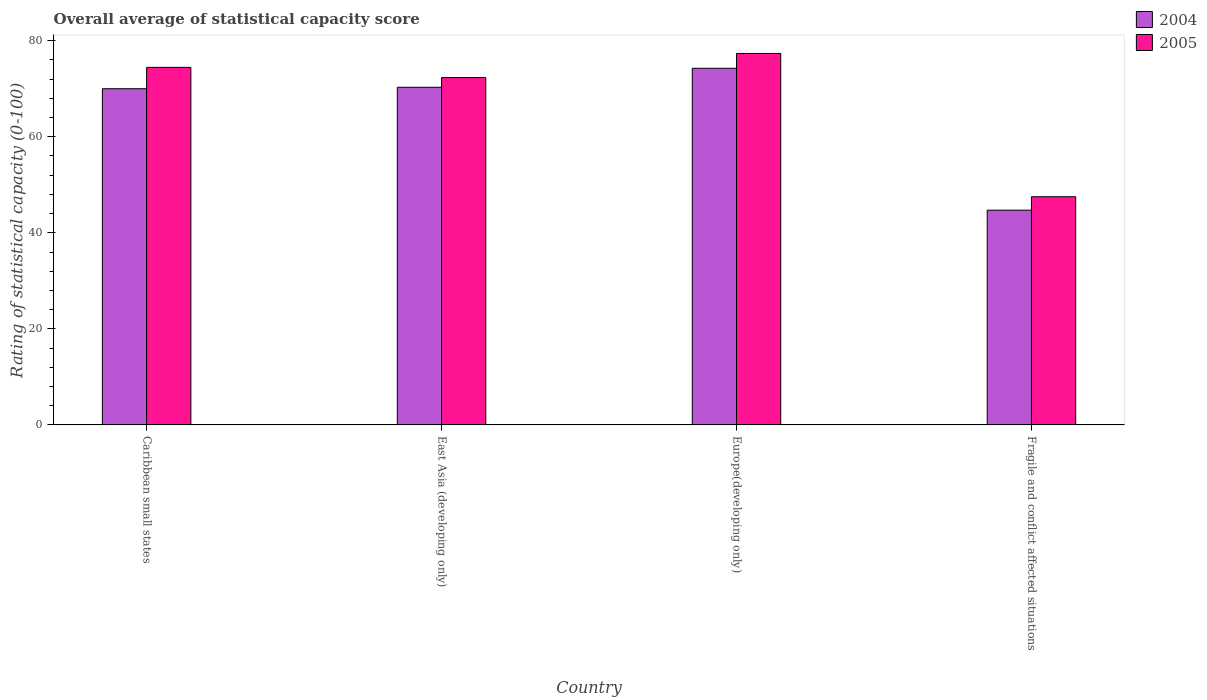How many groups of bars are there?
Offer a very short reply. 4. Are the number of bars per tick equal to the number of legend labels?
Give a very brief answer. Yes. Are the number of bars on each tick of the X-axis equal?
Give a very brief answer. Yes. How many bars are there on the 4th tick from the left?
Your response must be concise. 2. What is the label of the 3rd group of bars from the left?
Offer a very short reply. Europe(developing only). In how many cases, is the number of bars for a given country not equal to the number of legend labels?
Ensure brevity in your answer.  0. What is the rating of statistical capacity in 2004 in Europe(developing only)?
Make the answer very short. 74.26. Across all countries, what is the maximum rating of statistical capacity in 2005?
Provide a succinct answer. 77.35. Across all countries, what is the minimum rating of statistical capacity in 2005?
Keep it short and to the point. 47.51. In which country was the rating of statistical capacity in 2005 maximum?
Give a very brief answer. Europe(developing only). In which country was the rating of statistical capacity in 2005 minimum?
Provide a short and direct response. Fragile and conflict affected situations. What is the total rating of statistical capacity in 2004 in the graph?
Your answer should be very brief. 259.27. What is the difference between the rating of statistical capacity in 2004 in Caribbean small states and that in Europe(developing only)?
Give a very brief answer. -4.26. What is the difference between the rating of statistical capacity in 2004 in Fragile and conflict affected situations and the rating of statistical capacity in 2005 in Europe(developing only)?
Offer a very short reply. -32.63. What is the average rating of statistical capacity in 2005 per country?
Offer a terse response. 67.91. What is the difference between the rating of statistical capacity of/in 2004 and rating of statistical capacity of/in 2005 in East Asia (developing only)?
Provide a succinct answer. -2.02. In how many countries, is the rating of statistical capacity in 2004 greater than 72?
Provide a succinct answer. 1. What is the ratio of the rating of statistical capacity in 2005 in Caribbean small states to that in Fragile and conflict affected situations?
Your response must be concise. 1.57. Is the rating of statistical capacity in 2004 in Caribbean small states less than that in Fragile and conflict affected situations?
Your answer should be compact. No. Is the difference between the rating of statistical capacity in 2004 in Caribbean small states and East Asia (developing only) greater than the difference between the rating of statistical capacity in 2005 in Caribbean small states and East Asia (developing only)?
Your response must be concise. No. What is the difference between the highest and the second highest rating of statistical capacity in 2004?
Your answer should be very brief. -4.26. What is the difference between the highest and the lowest rating of statistical capacity in 2004?
Your response must be concise. 29.55. Is the sum of the rating of statistical capacity in 2005 in Europe(developing only) and Fragile and conflict affected situations greater than the maximum rating of statistical capacity in 2004 across all countries?
Give a very brief answer. Yes. What does the 2nd bar from the left in East Asia (developing only) represents?
Offer a terse response. 2005. What does the 1st bar from the right in Fragile and conflict affected situations represents?
Provide a succinct answer. 2005. Are the values on the major ticks of Y-axis written in scientific E-notation?
Provide a succinct answer. No. Does the graph contain any zero values?
Offer a terse response. No. Does the graph contain grids?
Provide a short and direct response. No. Where does the legend appear in the graph?
Provide a short and direct response. Top right. How many legend labels are there?
Provide a succinct answer. 2. What is the title of the graph?
Offer a terse response. Overall average of statistical capacity score. Does "1968" appear as one of the legend labels in the graph?
Your answer should be very brief. No. What is the label or title of the Y-axis?
Your response must be concise. Rating of statistical capacity (0-100). What is the Rating of statistical capacity (0-100) in 2004 in Caribbean small states?
Make the answer very short. 70. What is the Rating of statistical capacity (0-100) of 2005 in Caribbean small states?
Provide a succinct answer. 74.44. What is the Rating of statistical capacity (0-100) of 2004 in East Asia (developing only)?
Offer a very short reply. 70.3. What is the Rating of statistical capacity (0-100) in 2005 in East Asia (developing only)?
Provide a short and direct response. 72.32. What is the Rating of statistical capacity (0-100) in 2004 in Europe(developing only)?
Provide a succinct answer. 74.26. What is the Rating of statistical capacity (0-100) in 2005 in Europe(developing only)?
Your answer should be compact. 77.35. What is the Rating of statistical capacity (0-100) of 2004 in Fragile and conflict affected situations?
Your answer should be compact. 44.71. What is the Rating of statistical capacity (0-100) in 2005 in Fragile and conflict affected situations?
Offer a terse response. 47.51. Across all countries, what is the maximum Rating of statistical capacity (0-100) in 2004?
Keep it short and to the point. 74.26. Across all countries, what is the maximum Rating of statistical capacity (0-100) of 2005?
Keep it short and to the point. 77.35. Across all countries, what is the minimum Rating of statistical capacity (0-100) in 2004?
Make the answer very short. 44.71. Across all countries, what is the minimum Rating of statistical capacity (0-100) in 2005?
Your answer should be very brief. 47.51. What is the total Rating of statistical capacity (0-100) in 2004 in the graph?
Provide a short and direct response. 259.27. What is the total Rating of statistical capacity (0-100) in 2005 in the graph?
Offer a terse response. 271.62. What is the difference between the Rating of statistical capacity (0-100) of 2004 in Caribbean small states and that in East Asia (developing only)?
Your response must be concise. -0.3. What is the difference between the Rating of statistical capacity (0-100) in 2005 in Caribbean small states and that in East Asia (developing only)?
Your answer should be very brief. 2.12. What is the difference between the Rating of statistical capacity (0-100) of 2004 in Caribbean small states and that in Europe(developing only)?
Offer a very short reply. -4.26. What is the difference between the Rating of statistical capacity (0-100) in 2005 in Caribbean small states and that in Europe(developing only)?
Your answer should be compact. -2.9. What is the difference between the Rating of statistical capacity (0-100) in 2004 in Caribbean small states and that in Fragile and conflict affected situations?
Ensure brevity in your answer.  25.29. What is the difference between the Rating of statistical capacity (0-100) of 2005 in Caribbean small states and that in Fragile and conflict affected situations?
Provide a short and direct response. 26.93. What is the difference between the Rating of statistical capacity (0-100) in 2004 in East Asia (developing only) and that in Europe(developing only)?
Keep it short and to the point. -3.96. What is the difference between the Rating of statistical capacity (0-100) in 2005 in East Asia (developing only) and that in Europe(developing only)?
Offer a terse response. -5.02. What is the difference between the Rating of statistical capacity (0-100) of 2004 in East Asia (developing only) and that in Fragile and conflict affected situations?
Keep it short and to the point. 25.59. What is the difference between the Rating of statistical capacity (0-100) in 2005 in East Asia (developing only) and that in Fragile and conflict affected situations?
Offer a very short reply. 24.81. What is the difference between the Rating of statistical capacity (0-100) in 2004 in Europe(developing only) and that in Fragile and conflict affected situations?
Your answer should be compact. 29.55. What is the difference between the Rating of statistical capacity (0-100) in 2005 in Europe(developing only) and that in Fragile and conflict affected situations?
Provide a succinct answer. 29.83. What is the difference between the Rating of statistical capacity (0-100) of 2004 in Caribbean small states and the Rating of statistical capacity (0-100) of 2005 in East Asia (developing only)?
Make the answer very short. -2.32. What is the difference between the Rating of statistical capacity (0-100) of 2004 in Caribbean small states and the Rating of statistical capacity (0-100) of 2005 in Europe(developing only)?
Ensure brevity in your answer.  -7.35. What is the difference between the Rating of statistical capacity (0-100) of 2004 in Caribbean small states and the Rating of statistical capacity (0-100) of 2005 in Fragile and conflict affected situations?
Your response must be concise. 22.49. What is the difference between the Rating of statistical capacity (0-100) of 2004 in East Asia (developing only) and the Rating of statistical capacity (0-100) of 2005 in Europe(developing only)?
Your answer should be very brief. -7.04. What is the difference between the Rating of statistical capacity (0-100) in 2004 in East Asia (developing only) and the Rating of statistical capacity (0-100) in 2005 in Fragile and conflict affected situations?
Give a very brief answer. 22.79. What is the difference between the Rating of statistical capacity (0-100) of 2004 in Europe(developing only) and the Rating of statistical capacity (0-100) of 2005 in Fragile and conflict affected situations?
Ensure brevity in your answer.  26.75. What is the average Rating of statistical capacity (0-100) in 2004 per country?
Your response must be concise. 64.82. What is the average Rating of statistical capacity (0-100) in 2005 per country?
Your answer should be compact. 67.91. What is the difference between the Rating of statistical capacity (0-100) of 2004 and Rating of statistical capacity (0-100) of 2005 in Caribbean small states?
Provide a short and direct response. -4.44. What is the difference between the Rating of statistical capacity (0-100) of 2004 and Rating of statistical capacity (0-100) of 2005 in East Asia (developing only)?
Your response must be concise. -2.02. What is the difference between the Rating of statistical capacity (0-100) in 2004 and Rating of statistical capacity (0-100) in 2005 in Europe(developing only)?
Offer a terse response. -3.09. What is the ratio of the Rating of statistical capacity (0-100) of 2004 in Caribbean small states to that in East Asia (developing only)?
Your response must be concise. 1. What is the ratio of the Rating of statistical capacity (0-100) in 2005 in Caribbean small states to that in East Asia (developing only)?
Your answer should be compact. 1.03. What is the ratio of the Rating of statistical capacity (0-100) of 2004 in Caribbean small states to that in Europe(developing only)?
Your answer should be compact. 0.94. What is the ratio of the Rating of statistical capacity (0-100) of 2005 in Caribbean small states to that in Europe(developing only)?
Offer a terse response. 0.96. What is the ratio of the Rating of statistical capacity (0-100) in 2004 in Caribbean small states to that in Fragile and conflict affected situations?
Offer a very short reply. 1.57. What is the ratio of the Rating of statistical capacity (0-100) of 2005 in Caribbean small states to that in Fragile and conflict affected situations?
Ensure brevity in your answer.  1.57. What is the ratio of the Rating of statistical capacity (0-100) of 2004 in East Asia (developing only) to that in Europe(developing only)?
Your answer should be compact. 0.95. What is the ratio of the Rating of statistical capacity (0-100) of 2005 in East Asia (developing only) to that in Europe(developing only)?
Give a very brief answer. 0.94. What is the ratio of the Rating of statistical capacity (0-100) of 2004 in East Asia (developing only) to that in Fragile and conflict affected situations?
Offer a terse response. 1.57. What is the ratio of the Rating of statistical capacity (0-100) of 2005 in East Asia (developing only) to that in Fragile and conflict affected situations?
Make the answer very short. 1.52. What is the ratio of the Rating of statistical capacity (0-100) of 2004 in Europe(developing only) to that in Fragile and conflict affected situations?
Provide a succinct answer. 1.66. What is the ratio of the Rating of statistical capacity (0-100) of 2005 in Europe(developing only) to that in Fragile and conflict affected situations?
Your answer should be compact. 1.63. What is the difference between the highest and the second highest Rating of statistical capacity (0-100) in 2004?
Give a very brief answer. 3.96. What is the difference between the highest and the second highest Rating of statistical capacity (0-100) in 2005?
Provide a succinct answer. 2.9. What is the difference between the highest and the lowest Rating of statistical capacity (0-100) in 2004?
Make the answer very short. 29.55. What is the difference between the highest and the lowest Rating of statistical capacity (0-100) of 2005?
Give a very brief answer. 29.83. 